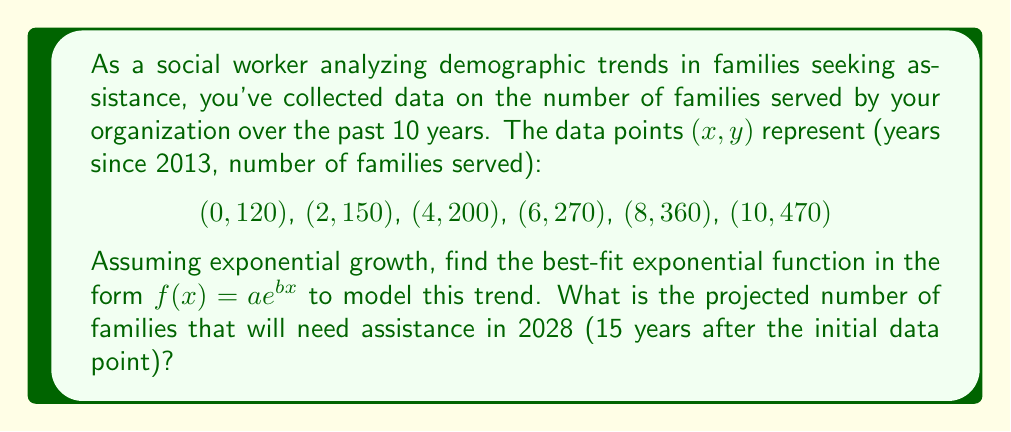Provide a solution to this math problem. Let's approach this step-by-step:

1) For exponential regression, we use the form $f(x) = ae^{bx}$. To find $a$ and $b$, we'll linearize the equation by taking the natural log of both sides:

   $\ln(y) = \ln(a) + bx$

2) Let $Y = \ln(y)$ and $A = \ln(a)$. Now we have a linear equation: $Y = A + bx$

3) Calculate $Y = \ln(y)$ for each data point:
   (0, 4.79), (2, 5.01), (4, 5.30), (6, 5.60), (8, 5.89), (10, 6.15)

4) Use the linear regression formulas:
   $b = \frac{n\sum(xy) - \sum x \sum y}{n\sum x^2 - (\sum x)^2}$
   $A = \bar{Y} - b\bar{x}$

   Where $n = 6$, $\sum x = 30$, $\sum Y = 32.74$, $\sum xy = 207.64$, $\sum x^2 = 220$

5) Calculating:
   $b = \frac{6(207.64) - 30(32.74)}{6(220) - 30^2} = 0.1357$
   $A = \frac{32.74}{6} - 0.1357(\frac{30}{6}) = 4.7843$

6) Therefore, $\ln(a) = 4.7843$, so $a = e^{4.7843} = 119.63$

7) Our exponential model is: $f(x) = 119.63e^{0.1357x}$

8) To project for 2028, we calculate $f(15)$:
   $f(15) = 119.63e^{0.1357(15)} = 119.63e^{2.0355} = 915.76$
Answer: 916 families (rounded to nearest whole number) 